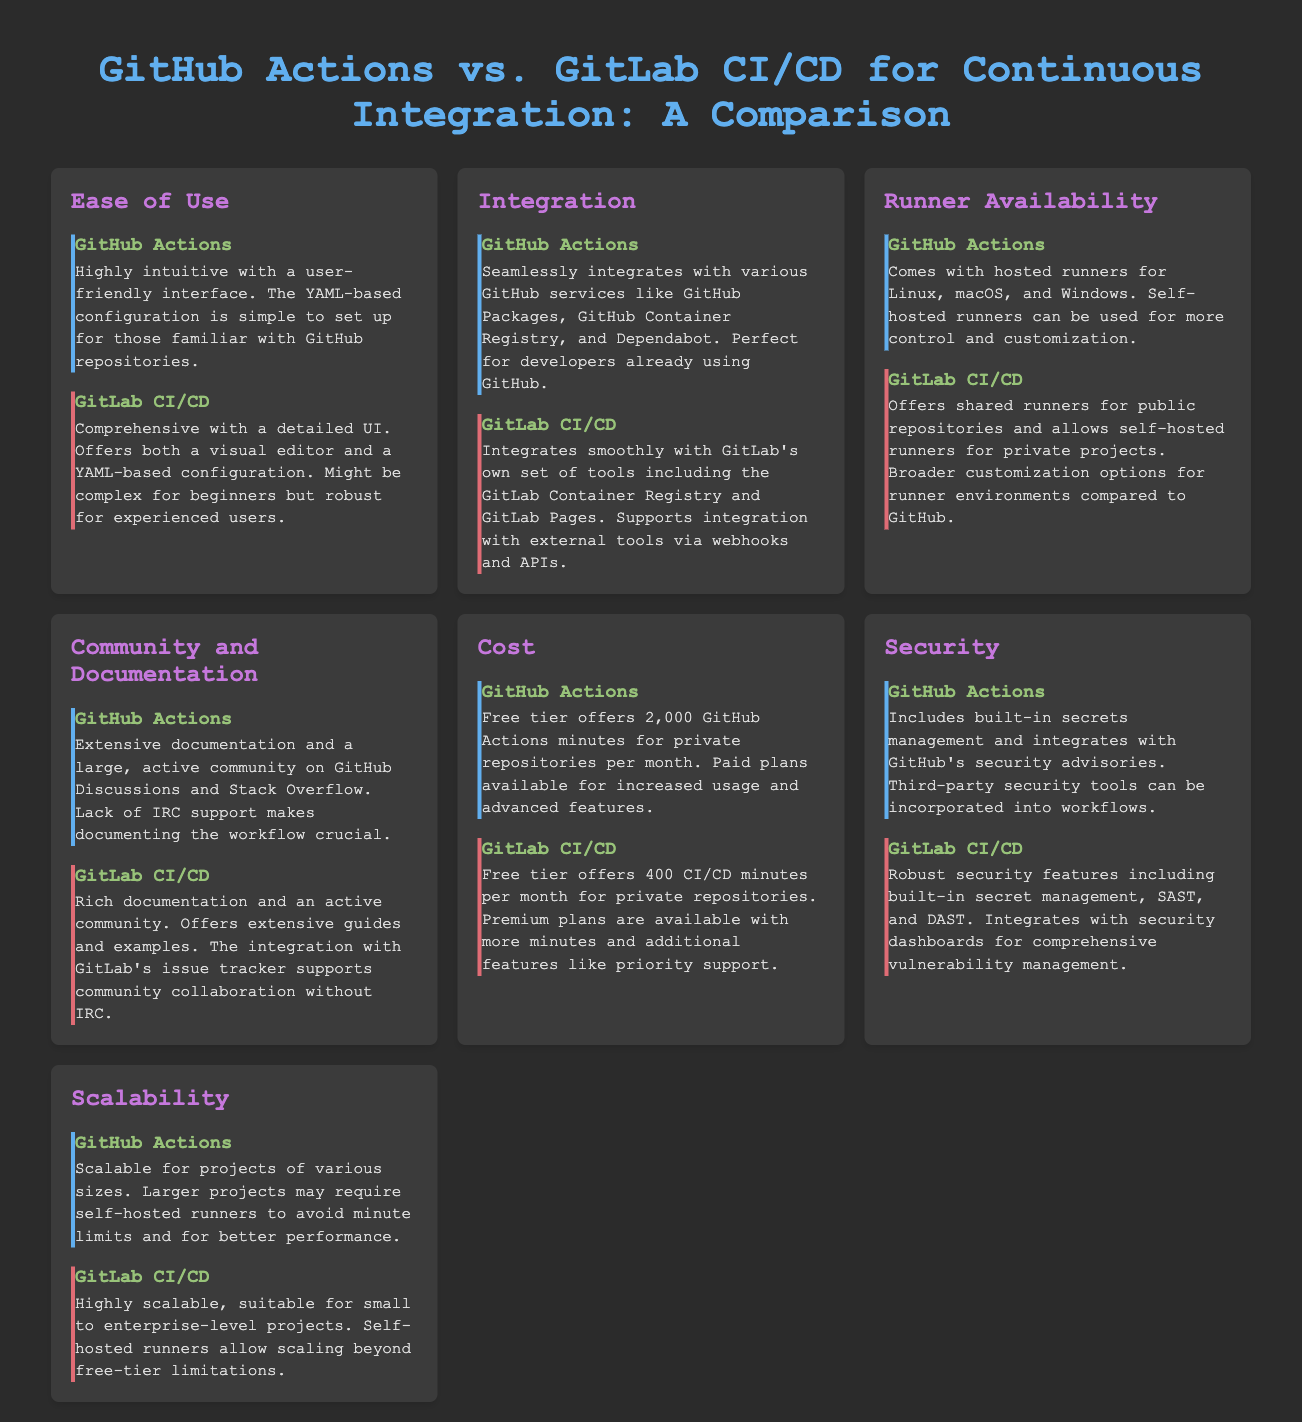What is the free tier limit of GitHub Actions for private repositories? The free tier offers 2,000 GitHub Actions minutes for private repositories per month.
Answer: 2,000 minutes What type of runners does GitHub Actions provide? GitHub Actions comes with hosted runners for Linux, macOS, and Windows, and self-hosted runners can be used.
Answer: Hosted runners Which CI/CD tool has a more comprehensive user interface? GitLab CI/CD offers a detailed UI and both a visual editor and YAML-based configuration.
Answer: GitLab CI/CD How many CI/CD minutes does GitLab CI/CD offer for private repositories on the free tier? The free tier offers 400 CI/CD minutes per month for private repositories.
Answer: 400 minutes What security feature is built into GitHub Actions? GitHub Actions includes built-in secrets management and integrates with GitHub's security advisories.
Answer: Secrets management Which platform integrates with its own tools like GitLab Pages? GitLab CI/CD integrates smoothly with GitLab's own set of tools.
Answer: GitLab CI/CD In terms of community support, which platform does not have IRC support? GitHub Actions lacks IRC support, making documentation of the workflow crucial.
Answer: GitHub Actions Which platform is described as scalable suitable for enterprise-level projects? GitLab CI/CD is described as highly scalable and suitable for small to enterprise-level projects.
Answer: GitLab CI/CD 